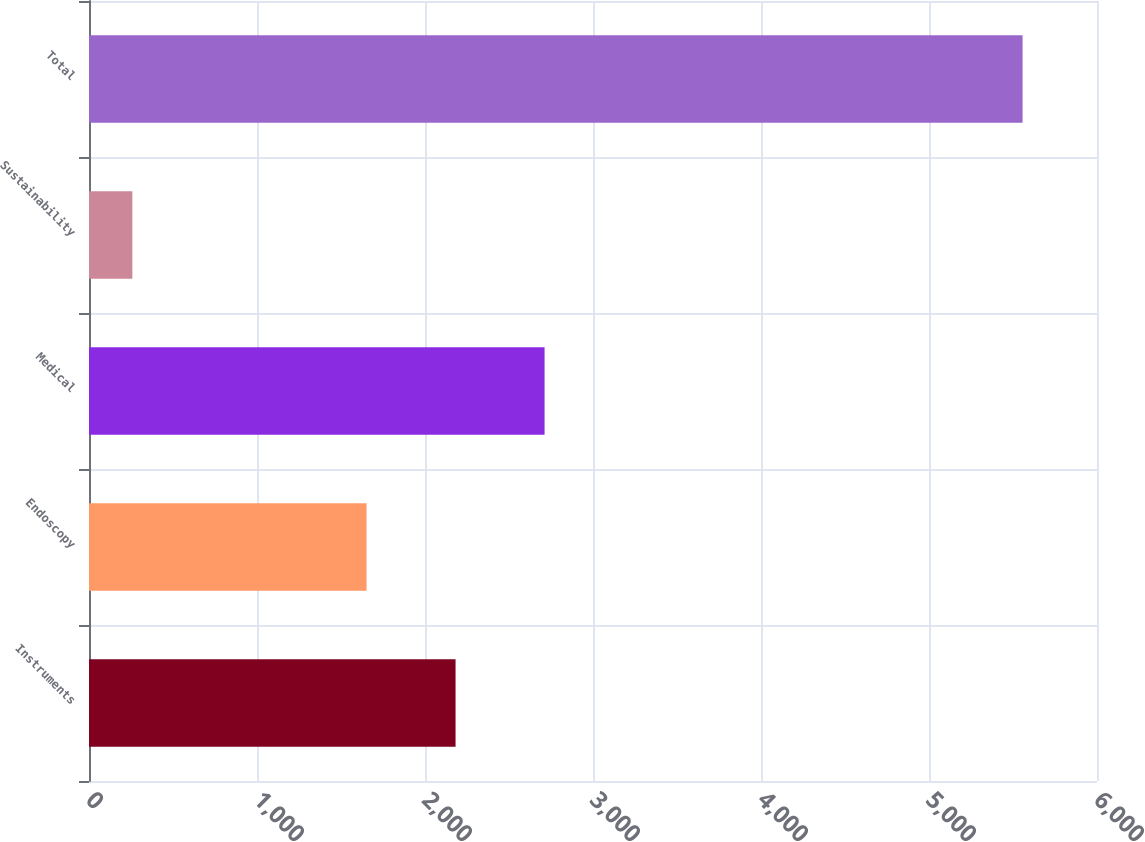Convert chart. <chart><loc_0><loc_0><loc_500><loc_500><bar_chart><fcel>Instruments<fcel>Endoscopy<fcel>Medical<fcel>Sustainability<fcel>Total<nl><fcel>2181.9<fcel>1652<fcel>2711.8<fcel>258<fcel>5557<nl></chart> 